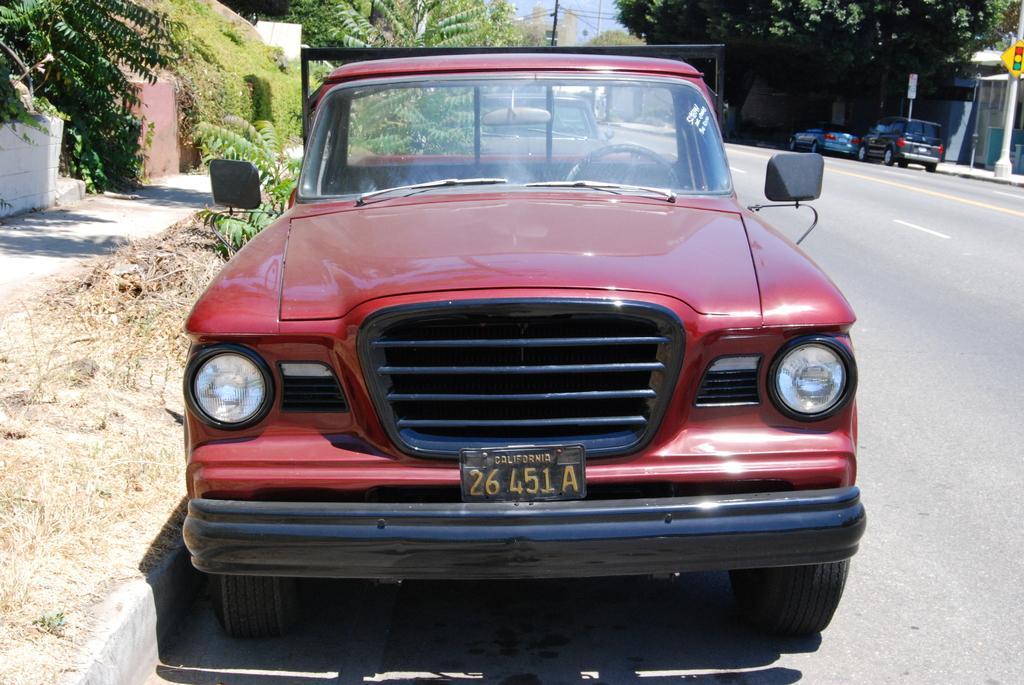How would you summarize this image in a sentence or two? In the center of the image there is a car on the road. In the background there are buildings, trees, poles, vehicles and sky. 